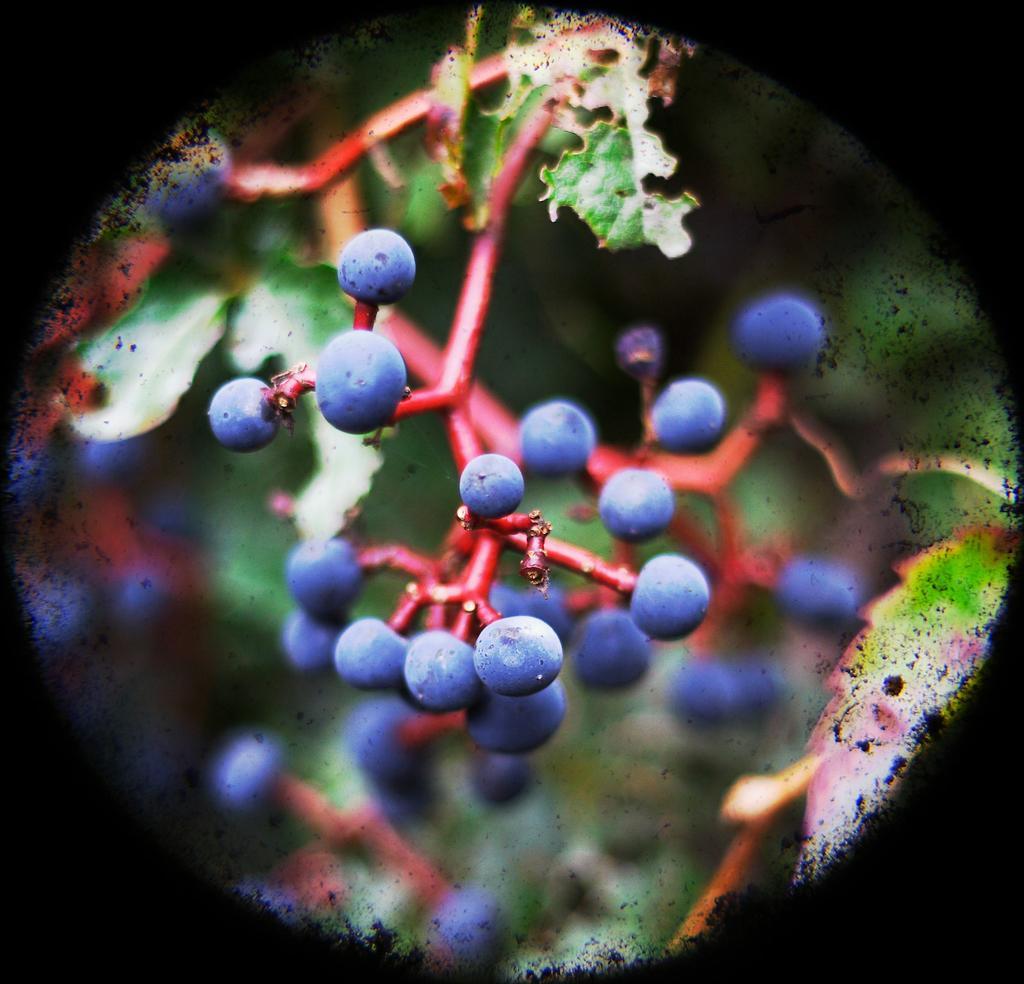Please provide a concise description of this image. In this image we can see a plant with berries and the image is edited with a circle frame. 